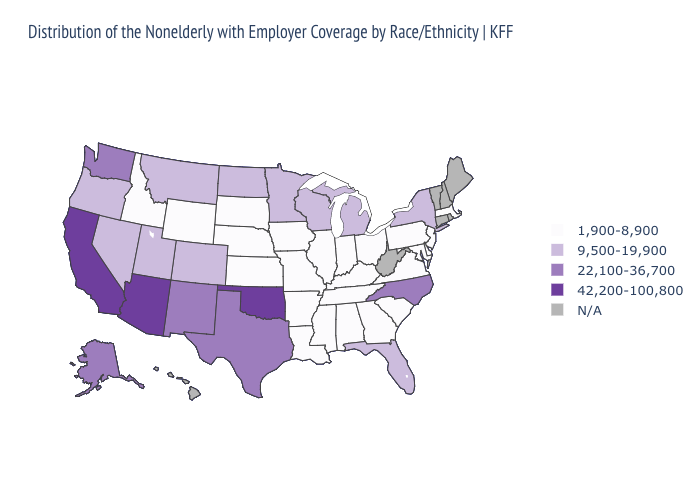Name the states that have a value in the range 42,200-100,800?
Be succinct. Arizona, California, Oklahoma. Is the legend a continuous bar?
Be succinct. No. Name the states that have a value in the range 22,100-36,700?
Short answer required. Alaska, New Mexico, North Carolina, Texas, Washington. Does Wisconsin have the lowest value in the MidWest?
Give a very brief answer. No. Which states hav the highest value in the South?
Concise answer only. Oklahoma. What is the highest value in states that border Vermont?
Short answer required. 9,500-19,900. Among the states that border Georgia , does North Carolina have the highest value?
Quick response, please. Yes. Which states hav the highest value in the Northeast?
Concise answer only. New York. Name the states that have a value in the range 22,100-36,700?
Concise answer only. Alaska, New Mexico, North Carolina, Texas, Washington. Does the first symbol in the legend represent the smallest category?
Quick response, please. Yes. What is the lowest value in the MidWest?
Give a very brief answer. 1,900-8,900. Is the legend a continuous bar?
Concise answer only. No. Among the states that border Illinois , which have the lowest value?
Answer briefly. Indiana, Iowa, Kentucky, Missouri. Name the states that have a value in the range 42,200-100,800?
Short answer required. Arizona, California, Oklahoma. 